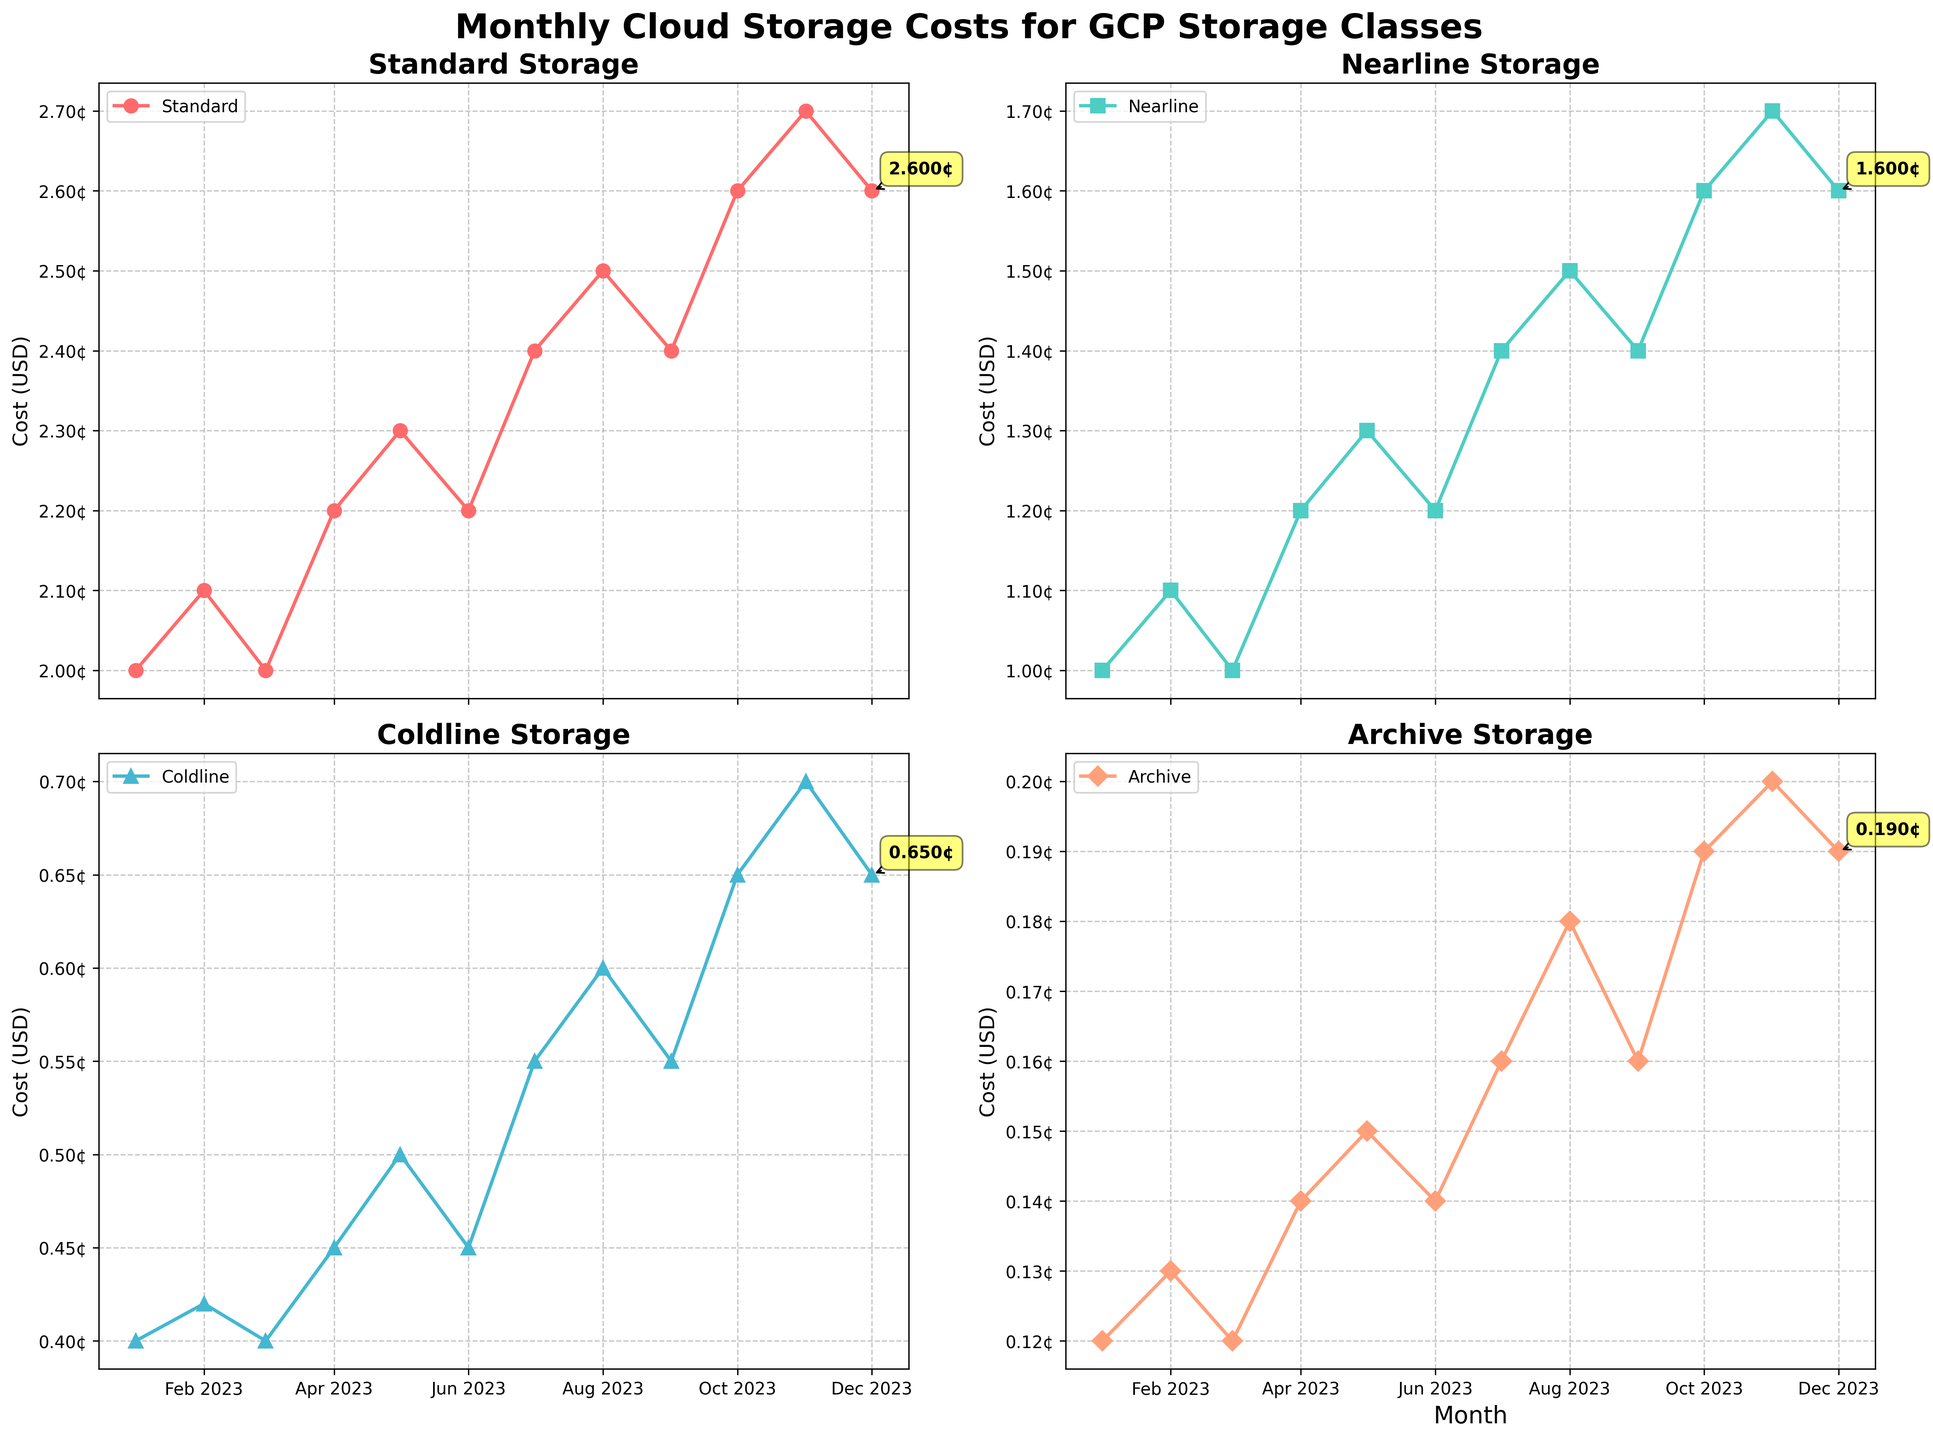How many GCP storage classes are displayed in the figure? By observing the legend and the titles of each subplot, you can count the number of different storage classes.
Answer: 4 What is the cost trend for the 'Nearline' storage class over the year? Look at the 'Nearline Storage' subplot and trace the line from January to December. You’ll see the cost starts lower and generally increases throughout the year.
Answer: Increasing What was the cost of 'Standard' storage in July 2023? Locate the 'Standard Storage' subplot, find the data point for July 2023, and read its value.
Answer: 0.024 USD Which storage class saw the highest cost increase from January to December 2023? Compare the cost values in January and December for all storage classes. The storage class with the largest difference is the one with the highest increase.
Answer: Nearline How much did the 'Archive' storage cost differ between February and August 2023? Locate the 'Archive Storage' subplot and subtract the February cost from the August cost: 0.0018 - 0.0013 = 0.0005 USD.
Answer: 0.0005 USD What was the average cost of 'Coldline' storage throughout 2023? Calculate the average by adding all monthly costs of 'Coldline' storage and dividing by 12: (0.004 + 0.0042 + 0.004 + 0.0045 + 0.005 + 0.0045 + 0.0055 + 0.006 + 0.0055 + 0.0065 + 0.007 + 0.0065) / 12.
Answer: 0.0051 USD In which month did 'Standard' storage cost reach its peak? Find the highest point in the 'Standard Storage' subplot. The peak is in November 2023.
Answer: November 2023 What is the maximum cost difference observed in 'Coldline' storage between any two months in 2023? Find the maximum and minimum values for 'Coldline' costs and subtract: 0.007 - 0.004 = 0.003 USD.
Answer: 0.003 USD Did any of the storage classes have a cost lower in December 2023 than in January 2023? Compare the December and January values for all storage classes. None of the storage classes show a decrease.
Answer: No Which storage class had the smallest cost increase from September to October 2023? Compare the September and October costs for each storage class: the smallest increase is observed in 'Coldline' storage (0.0055 to 0.006).
Answer: Coldline 